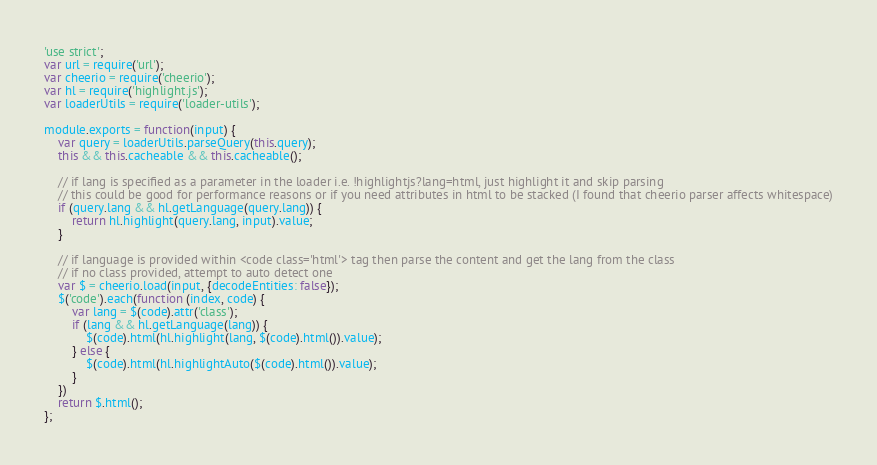<code> <loc_0><loc_0><loc_500><loc_500><_JavaScript_>'use strict';
var url = require('url');
var cheerio = require('cheerio');
var hl = require('highlight.js');
var loaderUtils = require('loader-utils');

module.exports = function(input) {
    var query = loaderUtils.parseQuery(this.query);
    this && this.cacheable && this.cacheable();
    
    // if lang is specified as a parameter in the loader i.e. !highlightjs?lang=html, just highlight it and skip parsing
    // this could be good for performance reasons or if you need attributes in html to be stacked (I found that cheerio parser affects whitespace)
    if (query.lang && hl.getLanguage(query.lang)) {
        return hl.highlight(query.lang, input).value;
    }

    // if language is provided within <code class='html'> tag then parse the content and get the lang from the class
    // if no class provided, attempt to auto detect one
    var $ = cheerio.load(input, {decodeEntities: false});
    $('code').each(function (index, code) {
        var lang = $(code).attr('class');
        if (lang && hl.getLanguage(lang)) {
            $(code).html(hl.highlight(lang, $(code).html()).value);
        } else {
            $(code).html(hl.highlightAuto($(code).html()).value);
        }
    })
    return $.html();
};
</code> 